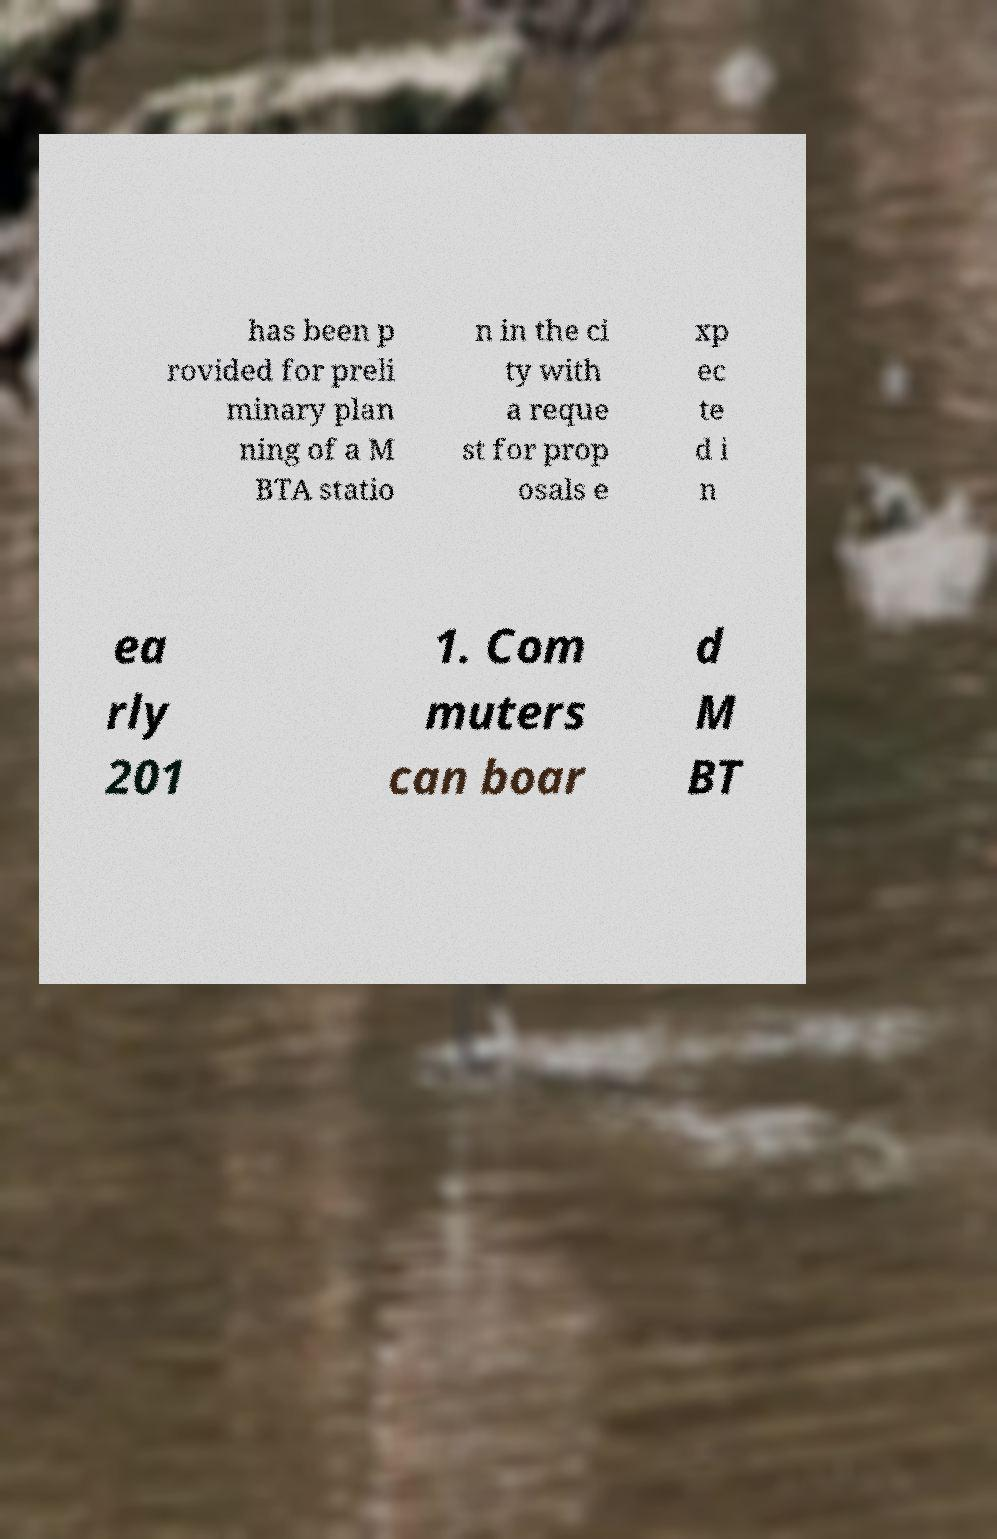There's text embedded in this image that I need extracted. Can you transcribe it verbatim? has been p rovided for preli minary plan ning of a M BTA statio n in the ci ty with a reque st for prop osals e xp ec te d i n ea rly 201 1. Com muters can boar d M BT 